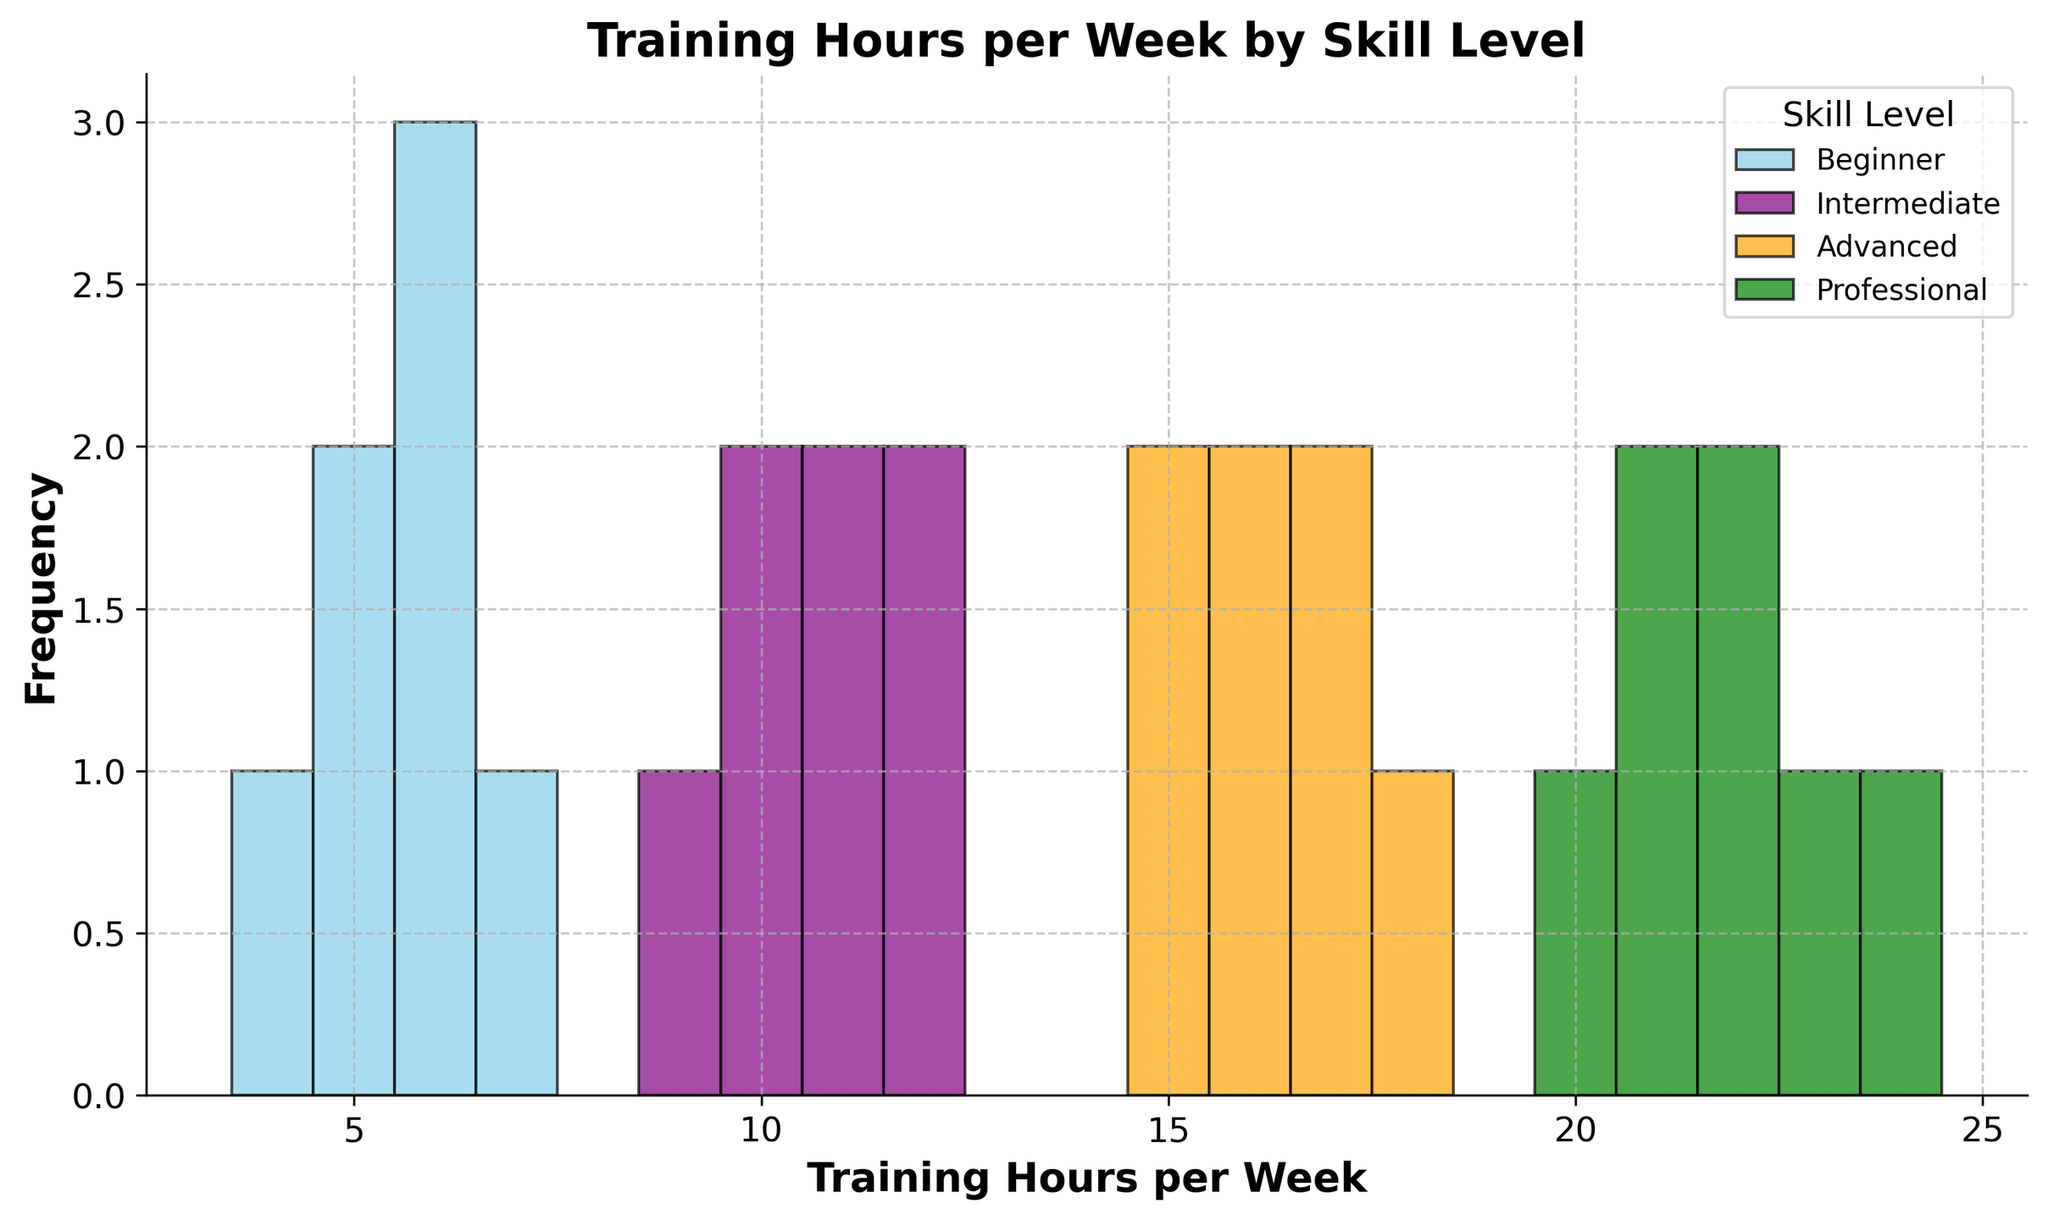Which skill level group has the highest training hours per week? Looking at the histogram, the Professional group has the highest training hours per week, ranging from 20 to 24 hours.
Answer: Professional What is the range of training hours for Intermediate players? The histogram indicates that the Intermediate group's training hours range from 9 to 12 hours per week.
Answer: 9 to 12 Which skill level has the most variation in training hours? By observing the width of the spread of bars within each skill level histogram, the Professional group shows the most variation, stretching from 20 to 24 hours.
Answer: Professional How does the average training hours per week for Advanced players compare to that of Beginner players? The training hours for Advanced players range from 15 to 18 hours, while for Beginners, it's from 4 to 7 hours. Both ranges can be summed and divided by the number of data points to find their averages.
Answer: Higher for Advanced Which group has the most overlap in training hours with another group? The histogram shows that the Intermediate and Advanced groups both cover the range from 10 to 12 hours, indicating the most overlap in their training hours.
Answer: Intermediate and Advanced What is the most common training hour for Professional players? By examining the heights of the histogram bars for the Professional group, the most frequent training hour appears to be 21 and 22 hours per week.
Answer: 21 and 22 Is there any skill level that has exactly 6 training hours per week? Observing the histogram, the Beginner group has a bar indicating that some players train exactly 6 hours per week.
Answer: Beginner Which skill level has the smallest range of training hours? The histogram indicates that the Beginner group's training hours range from 4 to 7 hours, which is the smallest range compared to other skill levels.
Answer: Beginner What is the maximum training hour for Intermediate players? The histogram for Intermediate players shows the highest bar reaching up to 12 hours per week.
Answer: 12 Are there any skill levels with the same minimum training hours? Both Beginner and Intermediate skill levels have their minimum training hours marked at 4 and 9 hours respectively, observing other groups, there are no overlaps at the minimum values.
Answer: No 